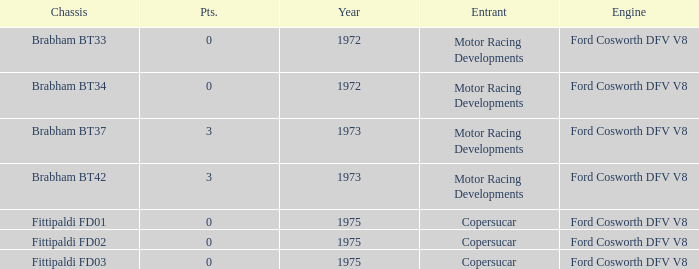Which engine from 1973 has a Brabham bt37 chassis? Ford Cosworth DFV V8. Write the full table. {'header': ['Chassis', 'Pts.', 'Year', 'Entrant', 'Engine'], 'rows': [['Brabham BT33', '0', '1972', 'Motor Racing Developments', 'Ford Cosworth DFV V8'], ['Brabham BT34', '0', '1972', 'Motor Racing Developments', 'Ford Cosworth DFV V8'], ['Brabham BT37', '3', '1973', 'Motor Racing Developments', 'Ford Cosworth DFV V8'], ['Brabham BT42', '3', '1973', 'Motor Racing Developments', 'Ford Cosworth DFV V8'], ['Fittipaldi FD01', '0', '1975', 'Copersucar', 'Ford Cosworth DFV V8'], ['Fittipaldi FD02', '0', '1975', 'Copersucar', 'Ford Cosworth DFV V8'], ['Fittipaldi FD03', '0', '1975', 'Copersucar', 'Ford Cosworth DFV V8']]} 